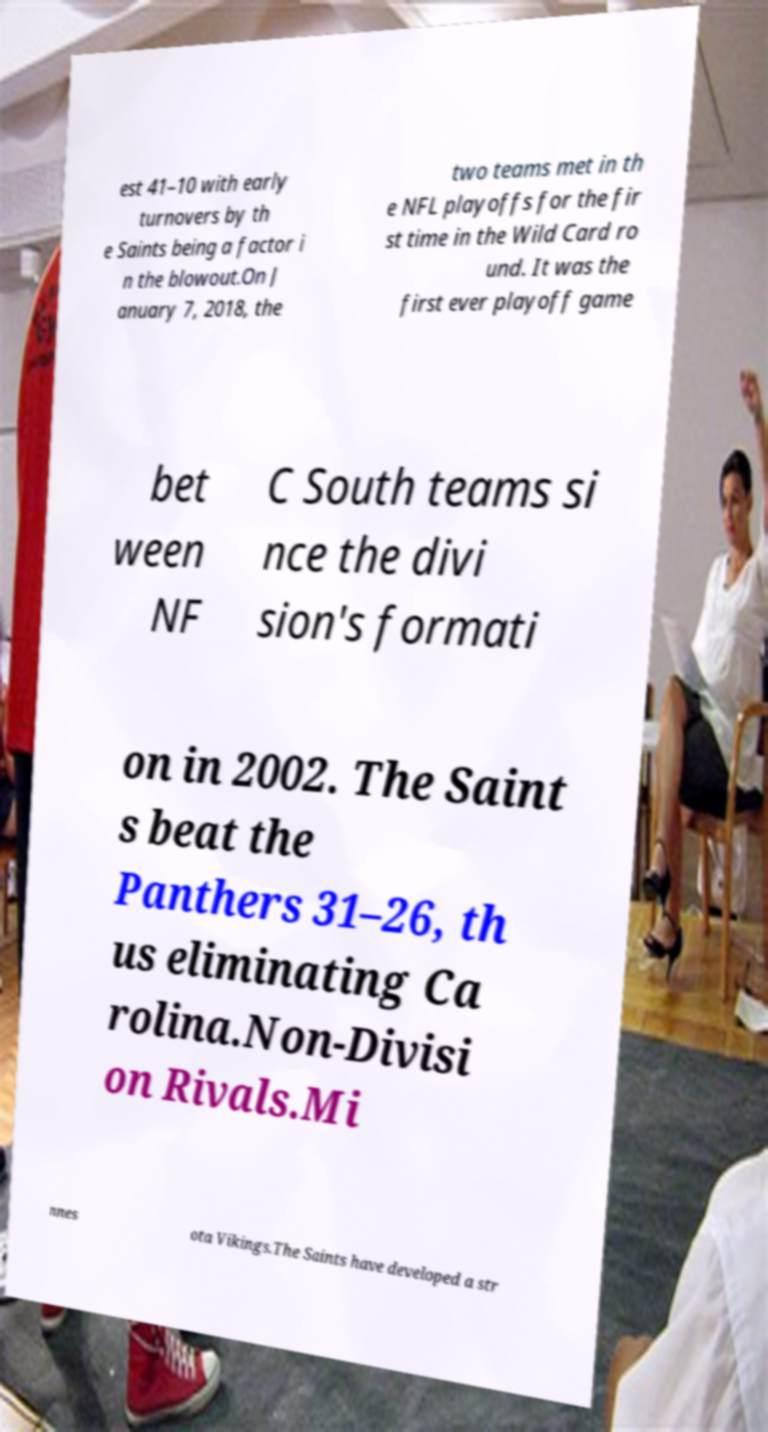Can you accurately transcribe the text from the provided image for me? est 41–10 with early turnovers by th e Saints being a factor i n the blowout.On J anuary 7, 2018, the two teams met in th e NFL playoffs for the fir st time in the Wild Card ro und. It was the first ever playoff game bet ween NF C South teams si nce the divi sion's formati on in 2002. The Saint s beat the Panthers 31–26, th us eliminating Ca rolina.Non-Divisi on Rivals.Mi nnes ota Vikings.The Saints have developed a str 